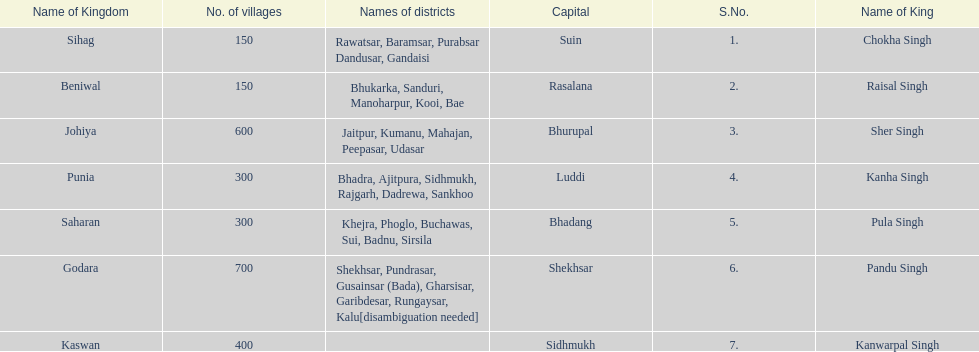What are the number of villages johiya has according to this chart? 600. 